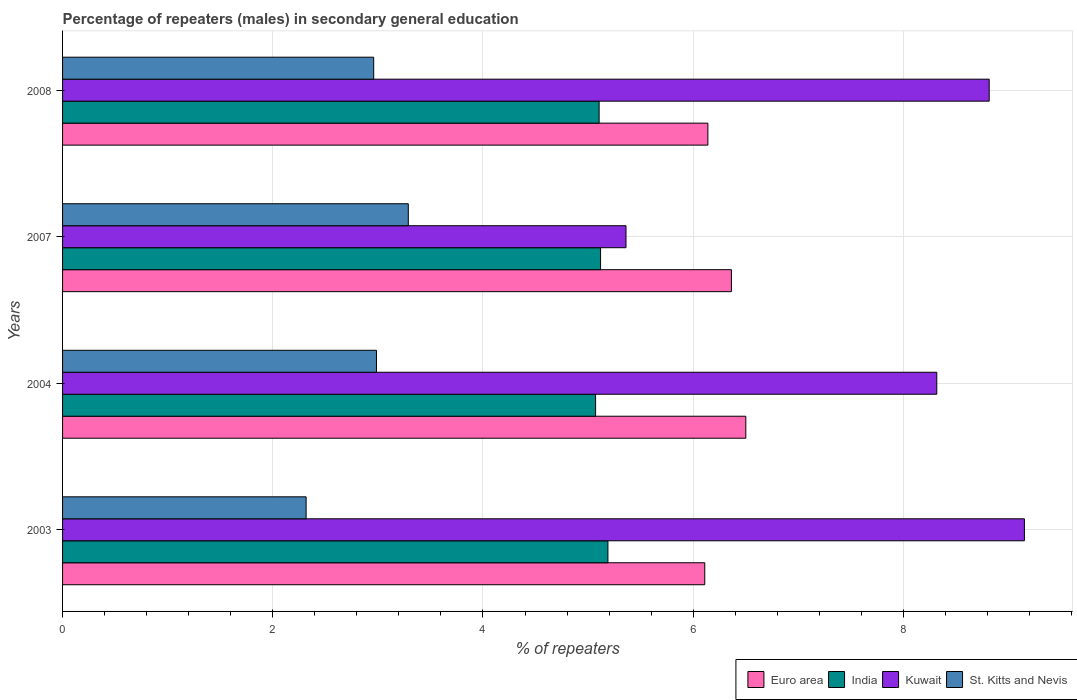Are the number of bars on each tick of the Y-axis equal?
Provide a short and direct response. Yes. How many bars are there on the 3rd tick from the bottom?
Your answer should be very brief. 4. What is the percentage of male repeaters in St. Kitts and Nevis in 2003?
Offer a very short reply. 2.32. Across all years, what is the maximum percentage of male repeaters in St. Kitts and Nevis?
Offer a terse response. 3.29. Across all years, what is the minimum percentage of male repeaters in Euro area?
Keep it short and to the point. 6.11. What is the total percentage of male repeaters in Kuwait in the graph?
Offer a terse response. 31.65. What is the difference between the percentage of male repeaters in Kuwait in 2004 and that in 2007?
Offer a very short reply. 2.96. What is the difference between the percentage of male repeaters in Kuwait in 2007 and the percentage of male repeaters in Euro area in 2003?
Offer a terse response. -0.75. What is the average percentage of male repeaters in Euro area per year?
Offer a very short reply. 6.28. In the year 2007, what is the difference between the percentage of male repeaters in India and percentage of male repeaters in St. Kitts and Nevis?
Ensure brevity in your answer.  1.83. What is the ratio of the percentage of male repeaters in St. Kitts and Nevis in 2007 to that in 2008?
Make the answer very short. 1.11. What is the difference between the highest and the second highest percentage of male repeaters in St. Kitts and Nevis?
Offer a terse response. 0.3. What is the difference between the highest and the lowest percentage of male repeaters in Kuwait?
Ensure brevity in your answer.  3.79. Is the sum of the percentage of male repeaters in Euro area in 2003 and 2004 greater than the maximum percentage of male repeaters in Kuwait across all years?
Keep it short and to the point. Yes. Is it the case that in every year, the sum of the percentage of male repeaters in St. Kitts and Nevis and percentage of male repeaters in Kuwait is greater than the sum of percentage of male repeaters in India and percentage of male repeaters in Euro area?
Give a very brief answer. Yes. What does the 4th bar from the bottom in 2007 represents?
Ensure brevity in your answer.  St. Kitts and Nevis. Are all the bars in the graph horizontal?
Offer a terse response. Yes. How many years are there in the graph?
Ensure brevity in your answer.  4. Are the values on the major ticks of X-axis written in scientific E-notation?
Keep it short and to the point. No. How are the legend labels stacked?
Your answer should be compact. Horizontal. What is the title of the graph?
Make the answer very short. Percentage of repeaters (males) in secondary general education. What is the label or title of the X-axis?
Make the answer very short. % of repeaters. What is the label or title of the Y-axis?
Your answer should be compact. Years. What is the % of repeaters of Euro area in 2003?
Ensure brevity in your answer.  6.11. What is the % of repeaters in India in 2003?
Offer a terse response. 5.19. What is the % of repeaters of Kuwait in 2003?
Your answer should be very brief. 9.15. What is the % of repeaters in St. Kitts and Nevis in 2003?
Keep it short and to the point. 2.32. What is the % of repeaters of Euro area in 2004?
Keep it short and to the point. 6.5. What is the % of repeaters of India in 2004?
Provide a short and direct response. 5.07. What is the % of repeaters in Kuwait in 2004?
Your response must be concise. 8.32. What is the % of repeaters of St. Kitts and Nevis in 2004?
Give a very brief answer. 2.99. What is the % of repeaters of Euro area in 2007?
Your response must be concise. 6.36. What is the % of repeaters in India in 2007?
Offer a terse response. 5.12. What is the % of repeaters of Kuwait in 2007?
Ensure brevity in your answer.  5.36. What is the % of repeaters in St. Kitts and Nevis in 2007?
Your answer should be compact. 3.29. What is the % of repeaters in Euro area in 2008?
Your response must be concise. 6.14. What is the % of repeaters in India in 2008?
Offer a terse response. 5.1. What is the % of repeaters of Kuwait in 2008?
Ensure brevity in your answer.  8.82. What is the % of repeaters in St. Kitts and Nevis in 2008?
Give a very brief answer. 2.96. Across all years, what is the maximum % of repeaters in Euro area?
Provide a succinct answer. 6.5. Across all years, what is the maximum % of repeaters in India?
Your response must be concise. 5.19. Across all years, what is the maximum % of repeaters in Kuwait?
Keep it short and to the point. 9.15. Across all years, what is the maximum % of repeaters of St. Kitts and Nevis?
Keep it short and to the point. 3.29. Across all years, what is the minimum % of repeaters of Euro area?
Your answer should be very brief. 6.11. Across all years, what is the minimum % of repeaters in India?
Offer a very short reply. 5.07. Across all years, what is the minimum % of repeaters in Kuwait?
Offer a very short reply. 5.36. Across all years, what is the minimum % of repeaters in St. Kitts and Nevis?
Your response must be concise. 2.32. What is the total % of repeaters of Euro area in the graph?
Make the answer very short. 25.11. What is the total % of repeaters in India in the graph?
Offer a very short reply. 20.48. What is the total % of repeaters of Kuwait in the graph?
Offer a terse response. 31.65. What is the total % of repeaters of St. Kitts and Nevis in the graph?
Make the answer very short. 11.55. What is the difference between the % of repeaters of Euro area in 2003 and that in 2004?
Your response must be concise. -0.39. What is the difference between the % of repeaters in India in 2003 and that in 2004?
Ensure brevity in your answer.  0.12. What is the difference between the % of repeaters in Kuwait in 2003 and that in 2004?
Your response must be concise. 0.83. What is the difference between the % of repeaters in St. Kitts and Nevis in 2003 and that in 2004?
Provide a succinct answer. -0.67. What is the difference between the % of repeaters in Euro area in 2003 and that in 2007?
Provide a succinct answer. -0.25. What is the difference between the % of repeaters in India in 2003 and that in 2007?
Provide a succinct answer. 0.07. What is the difference between the % of repeaters of Kuwait in 2003 and that in 2007?
Keep it short and to the point. 3.79. What is the difference between the % of repeaters in St. Kitts and Nevis in 2003 and that in 2007?
Your response must be concise. -0.97. What is the difference between the % of repeaters in Euro area in 2003 and that in 2008?
Make the answer very short. -0.03. What is the difference between the % of repeaters in India in 2003 and that in 2008?
Your answer should be very brief. 0.08. What is the difference between the % of repeaters in Kuwait in 2003 and that in 2008?
Offer a terse response. 0.33. What is the difference between the % of repeaters of St. Kitts and Nevis in 2003 and that in 2008?
Your response must be concise. -0.64. What is the difference between the % of repeaters in Euro area in 2004 and that in 2007?
Offer a terse response. 0.14. What is the difference between the % of repeaters in India in 2004 and that in 2007?
Your answer should be compact. -0.05. What is the difference between the % of repeaters of Kuwait in 2004 and that in 2007?
Make the answer very short. 2.96. What is the difference between the % of repeaters in St. Kitts and Nevis in 2004 and that in 2007?
Keep it short and to the point. -0.3. What is the difference between the % of repeaters of Euro area in 2004 and that in 2008?
Offer a very short reply. 0.36. What is the difference between the % of repeaters of India in 2004 and that in 2008?
Give a very brief answer. -0.03. What is the difference between the % of repeaters of Kuwait in 2004 and that in 2008?
Ensure brevity in your answer.  -0.5. What is the difference between the % of repeaters in St. Kitts and Nevis in 2004 and that in 2008?
Offer a terse response. 0.03. What is the difference between the % of repeaters in Euro area in 2007 and that in 2008?
Offer a terse response. 0.22. What is the difference between the % of repeaters in India in 2007 and that in 2008?
Offer a terse response. 0.01. What is the difference between the % of repeaters of Kuwait in 2007 and that in 2008?
Keep it short and to the point. -3.46. What is the difference between the % of repeaters of St. Kitts and Nevis in 2007 and that in 2008?
Offer a very short reply. 0.33. What is the difference between the % of repeaters in Euro area in 2003 and the % of repeaters in India in 2004?
Your response must be concise. 1.04. What is the difference between the % of repeaters of Euro area in 2003 and the % of repeaters of Kuwait in 2004?
Your answer should be very brief. -2.21. What is the difference between the % of repeaters of Euro area in 2003 and the % of repeaters of St. Kitts and Nevis in 2004?
Offer a terse response. 3.12. What is the difference between the % of repeaters of India in 2003 and the % of repeaters of Kuwait in 2004?
Provide a succinct answer. -3.13. What is the difference between the % of repeaters in India in 2003 and the % of repeaters in St. Kitts and Nevis in 2004?
Offer a very short reply. 2.2. What is the difference between the % of repeaters in Kuwait in 2003 and the % of repeaters in St. Kitts and Nevis in 2004?
Keep it short and to the point. 6.16. What is the difference between the % of repeaters in Euro area in 2003 and the % of repeaters in Kuwait in 2007?
Keep it short and to the point. 0.75. What is the difference between the % of repeaters of Euro area in 2003 and the % of repeaters of St. Kitts and Nevis in 2007?
Your response must be concise. 2.82. What is the difference between the % of repeaters of India in 2003 and the % of repeaters of Kuwait in 2007?
Provide a short and direct response. -0.17. What is the difference between the % of repeaters in India in 2003 and the % of repeaters in St. Kitts and Nevis in 2007?
Provide a succinct answer. 1.9. What is the difference between the % of repeaters of Kuwait in 2003 and the % of repeaters of St. Kitts and Nevis in 2007?
Keep it short and to the point. 5.86. What is the difference between the % of repeaters in Euro area in 2003 and the % of repeaters in India in 2008?
Give a very brief answer. 1.01. What is the difference between the % of repeaters in Euro area in 2003 and the % of repeaters in Kuwait in 2008?
Provide a short and direct response. -2.71. What is the difference between the % of repeaters in Euro area in 2003 and the % of repeaters in St. Kitts and Nevis in 2008?
Provide a succinct answer. 3.15. What is the difference between the % of repeaters of India in 2003 and the % of repeaters of Kuwait in 2008?
Your answer should be very brief. -3.63. What is the difference between the % of repeaters of India in 2003 and the % of repeaters of St. Kitts and Nevis in 2008?
Keep it short and to the point. 2.23. What is the difference between the % of repeaters of Kuwait in 2003 and the % of repeaters of St. Kitts and Nevis in 2008?
Provide a short and direct response. 6.19. What is the difference between the % of repeaters in Euro area in 2004 and the % of repeaters in India in 2007?
Keep it short and to the point. 1.38. What is the difference between the % of repeaters of Euro area in 2004 and the % of repeaters of Kuwait in 2007?
Keep it short and to the point. 1.14. What is the difference between the % of repeaters in Euro area in 2004 and the % of repeaters in St. Kitts and Nevis in 2007?
Make the answer very short. 3.21. What is the difference between the % of repeaters in India in 2004 and the % of repeaters in Kuwait in 2007?
Your answer should be compact. -0.29. What is the difference between the % of repeaters in India in 2004 and the % of repeaters in St. Kitts and Nevis in 2007?
Offer a very short reply. 1.78. What is the difference between the % of repeaters in Kuwait in 2004 and the % of repeaters in St. Kitts and Nevis in 2007?
Ensure brevity in your answer.  5.03. What is the difference between the % of repeaters in Euro area in 2004 and the % of repeaters in India in 2008?
Your answer should be compact. 1.4. What is the difference between the % of repeaters in Euro area in 2004 and the % of repeaters in Kuwait in 2008?
Offer a terse response. -2.32. What is the difference between the % of repeaters of Euro area in 2004 and the % of repeaters of St. Kitts and Nevis in 2008?
Provide a short and direct response. 3.54. What is the difference between the % of repeaters in India in 2004 and the % of repeaters in Kuwait in 2008?
Provide a short and direct response. -3.74. What is the difference between the % of repeaters in India in 2004 and the % of repeaters in St. Kitts and Nevis in 2008?
Offer a very short reply. 2.11. What is the difference between the % of repeaters of Kuwait in 2004 and the % of repeaters of St. Kitts and Nevis in 2008?
Your answer should be very brief. 5.36. What is the difference between the % of repeaters in Euro area in 2007 and the % of repeaters in India in 2008?
Your response must be concise. 1.26. What is the difference between the % of repeaters in Euro area in 2007 and the % of repeaters in Kuwait in 2008?
Give a very brief answer. -2.45. What is the difference between the % of repeaters of Euro area in 2007 and the % of repeaters of St. Kitts and Nevis in 2008?
Provide a succinct answer. 3.4. What is the difference between the % of repeaters in India in 2007 and the % of repeaters in Kuwait in 2008?
Offer a terse response. -3.7. What is the difference between the % of repeaters in India in 2007 and the % of repeaters in St. Kitts and Nevis in 2008?
Provide a succinct answer. 2.16. What is the difference between the % of repeaters in Kuwait in 2007 and the % of repeaters in St. Kitts and Nevis in 2008?
Your response must be concise. 2.4. What is the average % of repeaters in Euro area per year?
Ensure brevity in your answer.  6.28. What is the average % of repeaters in India per year?
Make the answer very short. 5.12. What is the average % of repeaters in Kuwait per year?
Offer a terse response. 7.91. What is the average % of repeaters in St. Kitts and Nevis per year?
Provide a succinct answer. 2.89. In the year 2003, what is the difference between the % of repeaters of Euro area and % of repeaters of India?
Your answer should be compact. 0.92. In the year 2003, what is the difference between the % of repeaters of Euro area and % of repeaters of Kuwait?
Your response must be concise. -3.04. In the year 2003, what is the difference between the % of repeaters in Euro area and % of repeaters in St. Kitts and Nevis?
Offer a very short reply. 3.79. In the year 2003, what is the difference between the % of repeaters in India and % of repeaters in Kuwait?
Your response must be concise. -3.96. In the year 2003, what is the difference between the % of repeaters of India and % of repeaters of St. Kitts and Nevis?
Offer a terse response. 2.87. In the year 2003, what is the difference between the % of repeaters of Kuwait and % of repeaters of St. Kitts and Nevis?
Your answer should be compact. 6.83. In the year 2004, what is the difference between the % of repeaters in Euro area and % of repeaters in India?
Provide a succinct answer. 1.43. In the year 2004, what is the difference between the % of repeaters in Euro area and % of repeaters in Kuwait?
Keep it short and to the point. -1.82. In the year 2004, what is the difference between the % of repeaters of Euro area and % of repeaters of St. Kitts and Nevis?
Ensure brevity in your answer.  3.51. In the year 2004, what is the difference between the % of repeaters of India and % of repeaters of Kuwait?
Give a very brief answer. -3.25. In the year 2004, what is the difference between the % of repeaters in India and % of repeaters in St. Kitts and Nevis?
Give a very brief answer. 2.08. In the year 2004, what is the difference between the % of repeaters in Kuwait and % of repeaters in St. Kitts and Nevis?
Your response must be concise. 5.33. In the year 2007, what is the difference between the % of repeaters of Euro area and % of repeaters of India?
Provide a short and direct response. 1.25. In the year 2007, what is the difference between the % of repeaters in Euro area and % of repeaters in St. Kitts and Nevis?
Your answer should be very brief. 3.07. In the year 2007, what is the difference between the % of repeaters of India and % of repeaters of Kuwait?
Offer a terse response. -0.24. In the year 2007, what is the difference between the % of repeaters of India and % of repeaters of St. Kitts and Nevis?
Offer a very short reply. 1.83. In the year 2007, what is the difference between the % of repeaters of Kuwait and % of repeaters of St. Kitts and Nevis?
Your response must be concise. 2.07. In the year 2008, what is the difference between the % of repeaters of Euro area and % of repeaters of India?
Give a very brief answer. 1.03. In the year 2008, what is the difference between the % of repeaters of Euro area and % of repeaters of Kuwait?
Ensure brevity in your answer.  -2.68. In the year 2008, what is the difference between the % of repeaters in Euro area and % of repeaters in St. Kitts and Nevis?
Offer a very short reply. 3.18. In the year 2008, what is the difference between the % of repeaters of India and % of repeaters of Kuwait?
Your answer should be very brief. -3.71. In the year 2008, what is the difference between the % of repeaters of India and % of repeaters of St. Kitts and Nevis?
Keep it short and to the point. 2.14. In the year 2008, what is the difference between the % of repeaters of Kuwait and % of repeaters of St. Kitts and Nevis?
Your answer should be compact. 5.86. What is the ratio of the % of repeaters of Euro area in 2003 to that in 2004?
Ensure brevity in your answer.  0.94. What is the ratio of the % of repeaters of India in 2003 to that in 2004?
Offer a terse response. 1.02. What is the ratio of the % of repeaters of Kuwait in 2003 to that in 2004?
Offer a terse response. 1.1. What is the ratio of the % of repeaters in St. Kitts and Nevis in 2003 to that in 2004?
Give a very brief answer. 0.78. What is the ratio of the % of repeaters in Euro area in 2003 to that in 2007?
Make the answer very short. 0.96. What is the ratio of the % of repeaters in India in 2003 to that in 2007?
Your answer should be compact. 1.01. What is the ratio of the % of repeaters in Kuwait in 2003 to that in 2007?
Keep it short and to the point. 1.71. What is the ratio of the % of repeaters of St. Kitts and Nevis in 2003 to that in 2007?
Your response must be concise. 0.7. What is the ratio of the % of repeaters of Euro area in 2003 to that in 2008?
Ensure brevity in your answer.  1. What is the ratio of the % of repeaters in India in 2003 to that in 2008?
Ensure brevity in your answer.  1.02. What is the ratio of the % of repeaters of Kuwait in 2003 to that in 2008?
Offer a terse response. 1.04. What is the ratio of the % of repeaters of St. Kitts and Nevis in 2003 to that in 2008?
Offer a very short reply. 0.78. What is the ratio of the % of repeaters in Euro area in 2004 to that in 2007?
Offer a terse response. 1.02. What is the ratio of the % of repeaters in Kuwait in 2004 to that in 2007?
Provide a succinct answer. 1.55. What is the ratio of the % of repeaters in St. Kitts and Nevis in 2004 to that in 2007?
Your answer should be very brief. 0.91. What is the ratio of the % of repeaters in Euro area in 2004 to that in 2008?
Keep it short and to the point. 1.06. What is the ratio of the % of repeaters of India in 2004 to that in 2008?
Make the answer very short. 0.99. What is the ratio of the % of repeaters in Kuwait in 2004 to that in 2008?
Your answer should be compact. 0.94. What is the ratio of the % of repeaters in St. Kitts and Nevis in 2004 to that in 2008?
Make the answer very short. 1.01. What is the ratio of the % of repeaters in Euro area in 2007 to that in 2008?
Your answer should be compact. 1.04. What is the ratio of the % of repeaters in India in 2007 to that in 2008?
Your answer should be very brief. 1. What is the ratio of the % of repeaters in Kuwait in 2007 to that in 2008?
Offer a very short reply. 0.61. What is the ratio of the % of repeaters in St. Kitts and Nevis in 2007 to that in 2008?
Ensure brevity in your answer.  1.11. What is the difference between the highest and the second highest % of repeaters of Euro area?
Provide a short and direct response. 0.14. What is the difference between the highest and the second highest % of repeaters in India?
Give a very brief answer. 0.07. What is the difference between the highest and the second highest % of repeaters in Kuwait?
Ensure brevity in your answer.  0.33. What is the difference between the highest and the second highest % of repeaters in St. Kitts and Nevis?
Your answer should be very brief. 0.3. What is the difference between the highest and the lowest % of repeaters of Euro area?
Keep it short and to the point. 0.39. What is the difference between the highest and the lowest % of repeaters in India?
Make the answer very short. 0.12. What is the difference between the highest and the lowest % of repeaters in Kuwait?
Offer a terse response. 3.79. What is the difference between the highest and the lowest % of repeaters in St. Kitts and Nevis?
Your response must be concise. 0.97. 